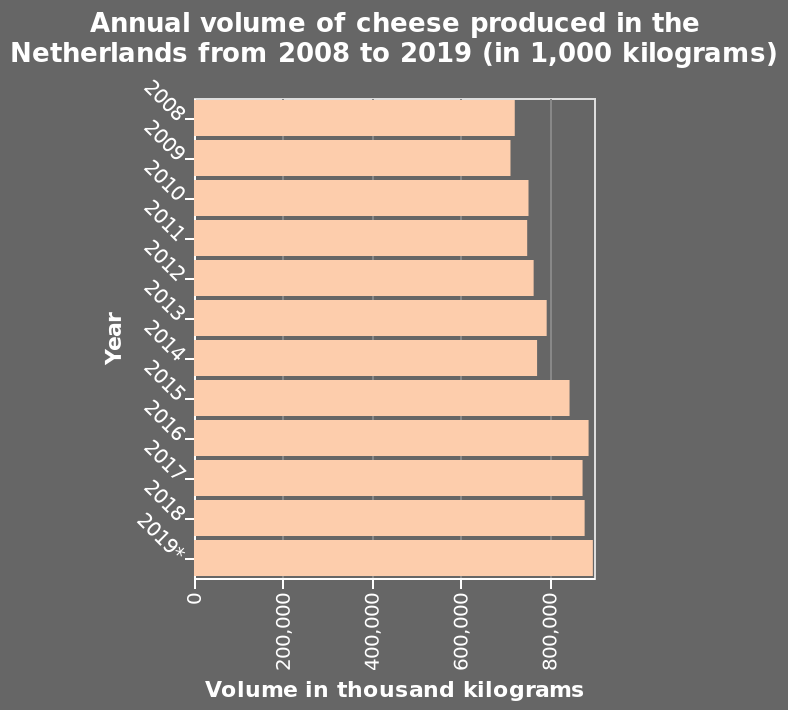<image>
What is the average annual increase in cheese production over the years? The description does not provide information about the average annual increase in cheese production. Can you provide an example of a year where there was a decrease in cheese production? Yes, there are specific years where we observe a decrease in cheese production compared to the previous year, although the description does not provide an example. What is the minimum volume of cheese produced in the Netherlands from 2008 to 2019?  The minimum volume of cheese produced in the Netherlands from 2008 to 2019 is 0 thousand kilograms. Is there always an increase in cheese production each year? No, there are some years where there is a decrease in cheese production compared to the previous year. What is the volume of cheese produced in the Netherlands in the year 2019?  The volume of cheese produced in the Netherlands in the year 2019 is not provided in the description. 